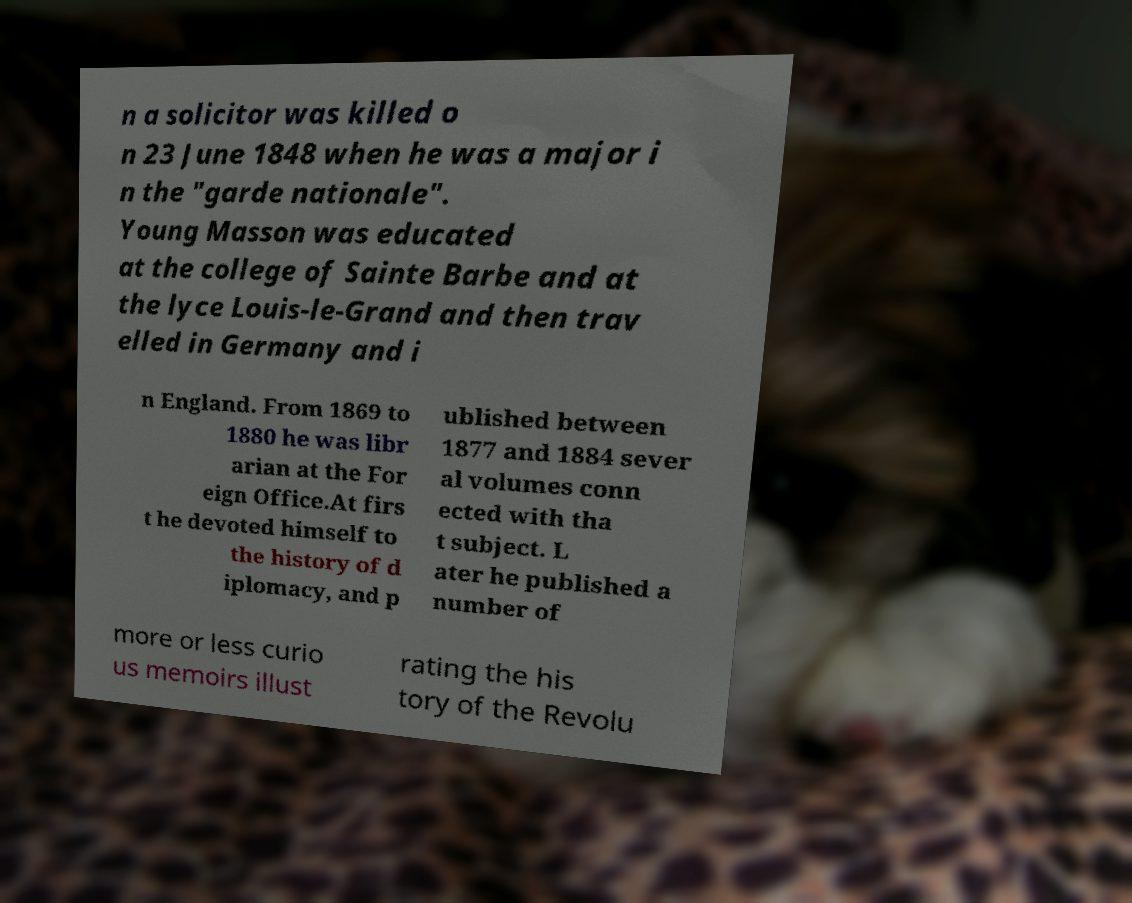Can you accurately transcribe the text from the provided image for me? n a solicitor was killed o n 23 June 1848 when he was a major i n the "garde nationale". Young Masson was educated at the college of Sainte Barbe and at the lyce Louis-le-Grand and then trav elled in Germany and i n England. From 1869 to 1880 he was libr arian at the For eign Office.At firs t he devoted himself to the history of d iplomacy, and p ublished between 1877 and 1884 sever al volumes conn ected with tha t subject. L ater he published a number of more or less curio us memoirs illust rating the his tory of the Revolu 